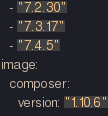Convert code to text. <code><loc_0><loc_0><loc_500><loc_500><_YAML_>  - "7.2.30"
  - "7.3.17"
  - "7.4.5"
image:
  composer:
    version: "1.10.6"
</code> 